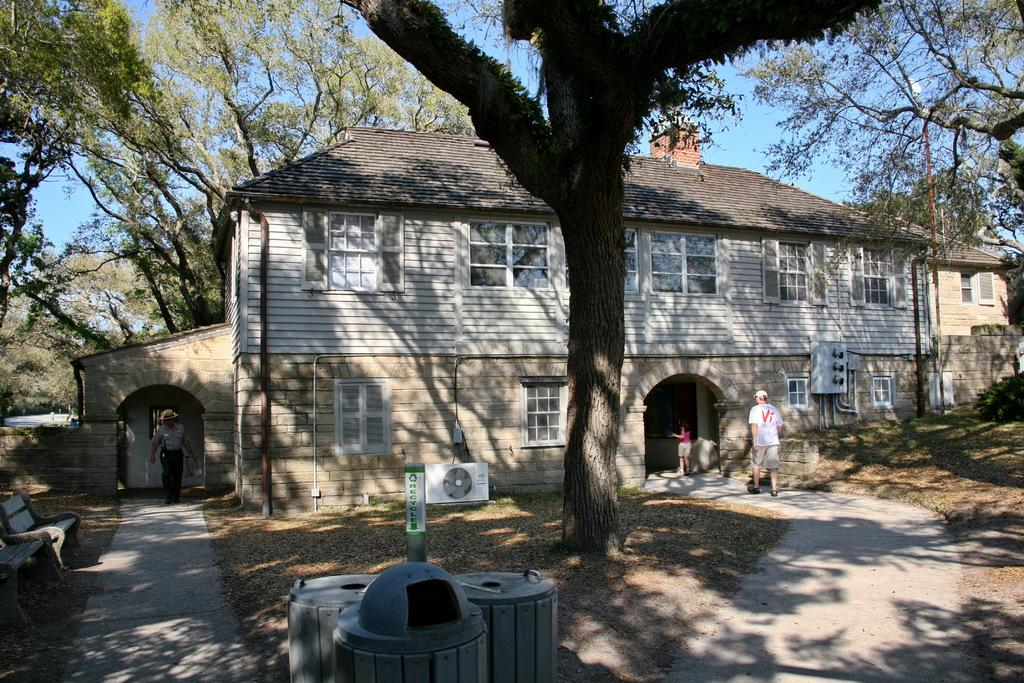What can be seen on the ground in the image? There are people on the ground in the image. What type of structures are present in the image? There are buildings in the image. What type of vegetation is visible in the image? There are trees in the image. What appliance can be seen in the image? There is an air conditioner in the image. What other objects are present in the image? There are other objects in the image. What is visible in the background of the image? The sky is visible in the background of the image. Can you hear the bell ringing in the image? There is no bell present in the image, so it cannot be heard. Are the people running in the image? The provided facts do not mention anyone running in the image. What type of lace is draped over the trees in the image? There is no lace present in the image; it only features people, buildings, trees, an air conditioner, other objects, and the sky. 